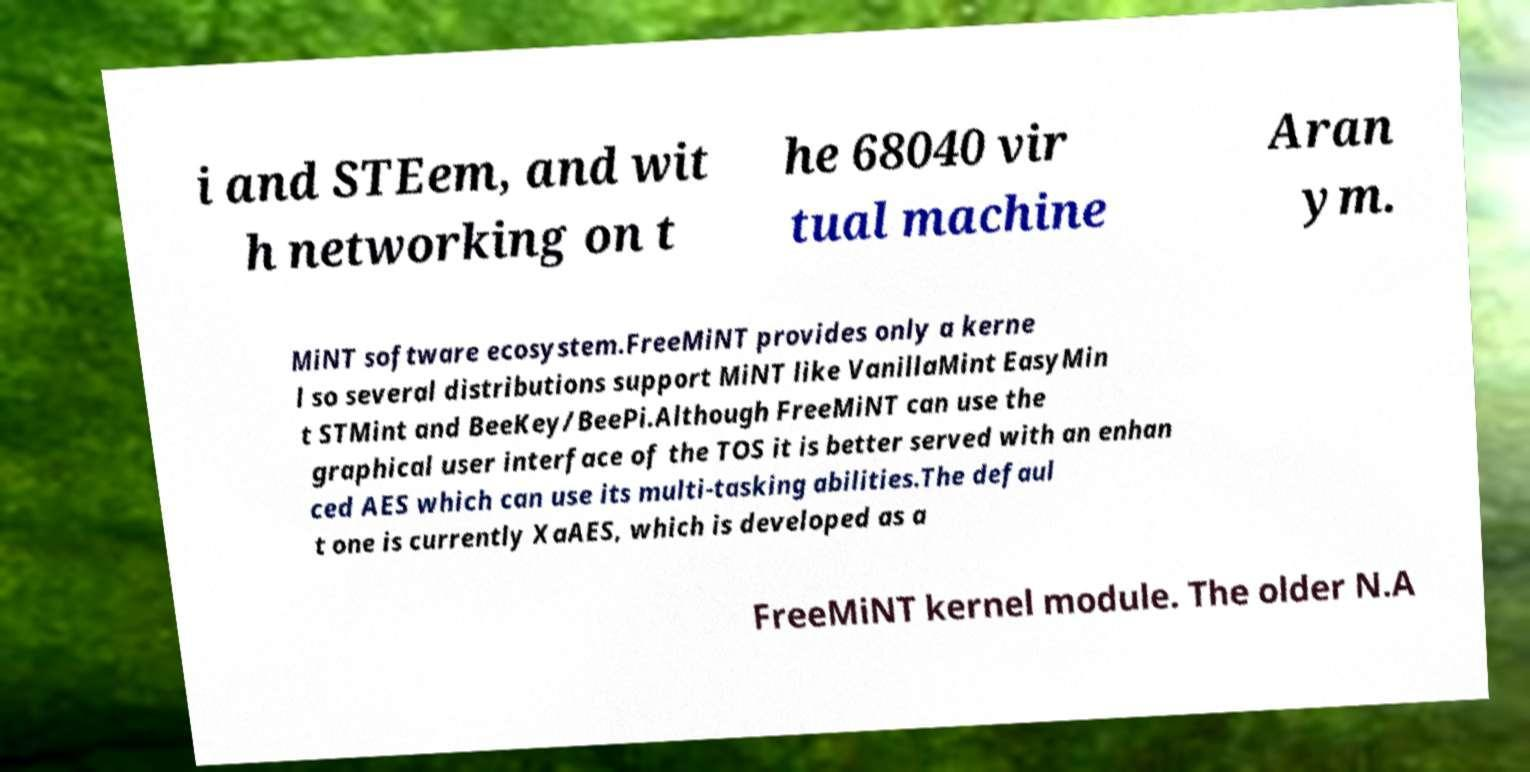Please read and relay the text visible in this image. What does it say? i and STEem, and wit h networking on t he 68040 vir tual machine Aran ym. MiNT software ecosystem.FreeMiNT provides only a kerne l so several distributions support MiNT like VanillaMint EasyMin t STMint and BeeKey/BeePi.Although FreeMiNT can use the graphical user interface of the TOS it is better served with an enhan ced AES which can use its multi-tasking abilities.The defaul t one is currently XaAES, which is developed as a FreeMiNT kernel module. The older N.A 